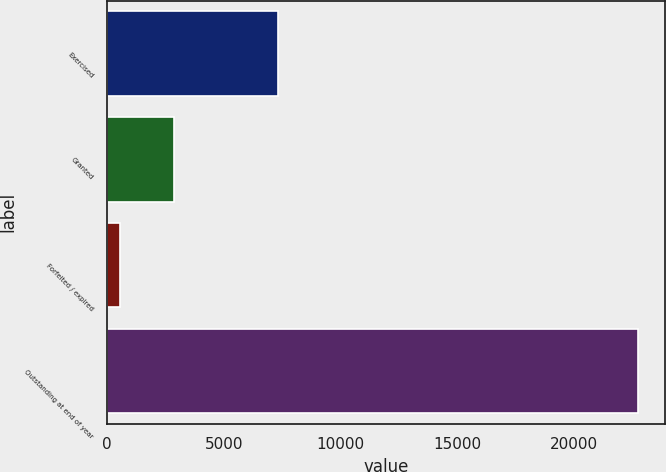<chart> <loc_0><loc_0><loc_500><loc_500><bar_chart><fcel>Exercised<fcel>Granted<fcel>Forfeited / expired<fcel>Outstanding at end of year<nl><fcel>7297<fcel>2860<fcel>563<fcel>22745<nl></chart> 